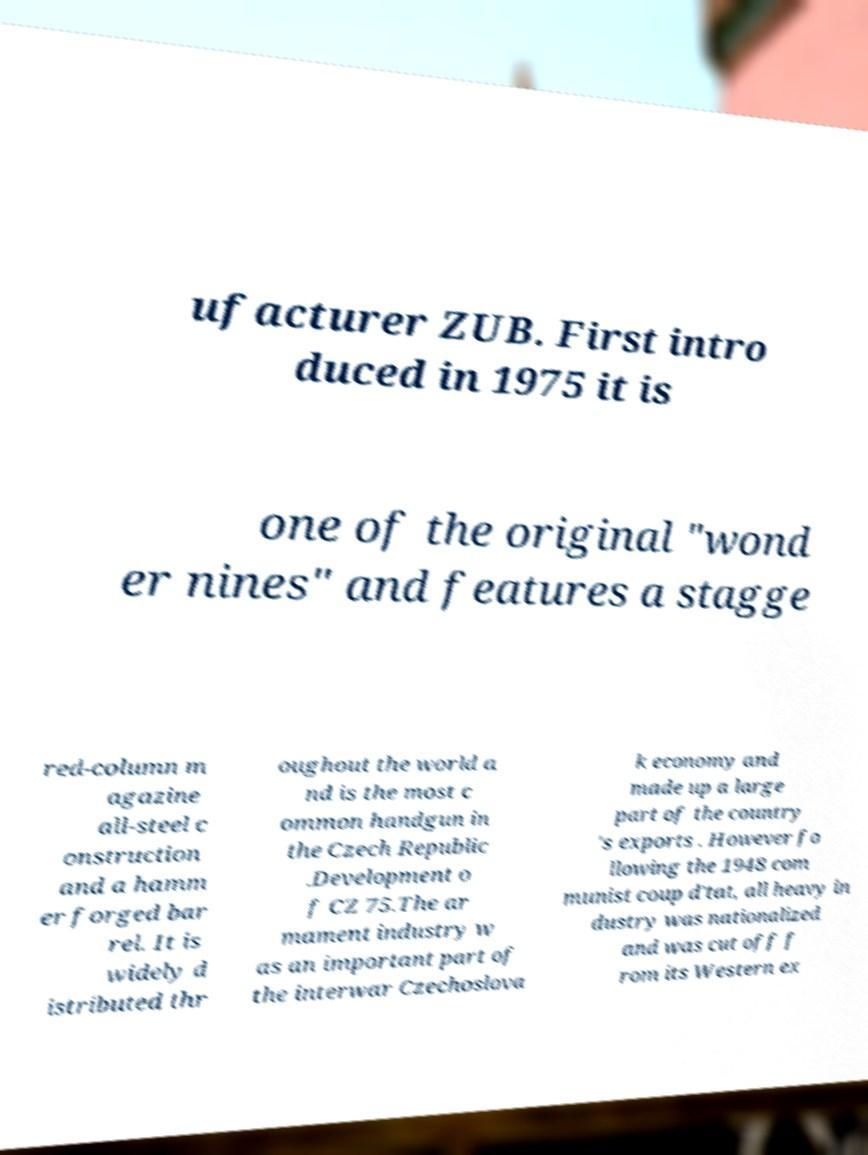Please read and relay the text visible in this image. What does it say? ufacturer ZUB. First intro duced in 1975 it is one of the original "wond er nines" and features a stagge red-column m agazine all-steel c onstruction and a hamm er forged bar rel. It is widely d istributed thr oughout the world a nd is the most c ommon handgun in the Czech Republic .Development o f CZ 75.The ar mament industry w as an important part of the interwar Czechoslova k economy and made up a large part of the country 's exports . However fo llowing the 1948 com munist coup d'tat, all heavy in dustry was nationalized and was cut off f rom its Western ex 